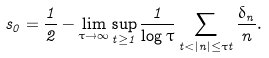Convert formula to latex. <formula><loc_0><loc_0><loc_500><loc_500>s _ { 0 } = \frac { 1 } { 2 } - \lim _ { \tau \to \infty } \sup _ { t \geq 1 } \frac { 1 } { \log \tau } \sum _ { t < | n | \leq \tau t } \frac { \delta _ { n } } { n } .</formula> 